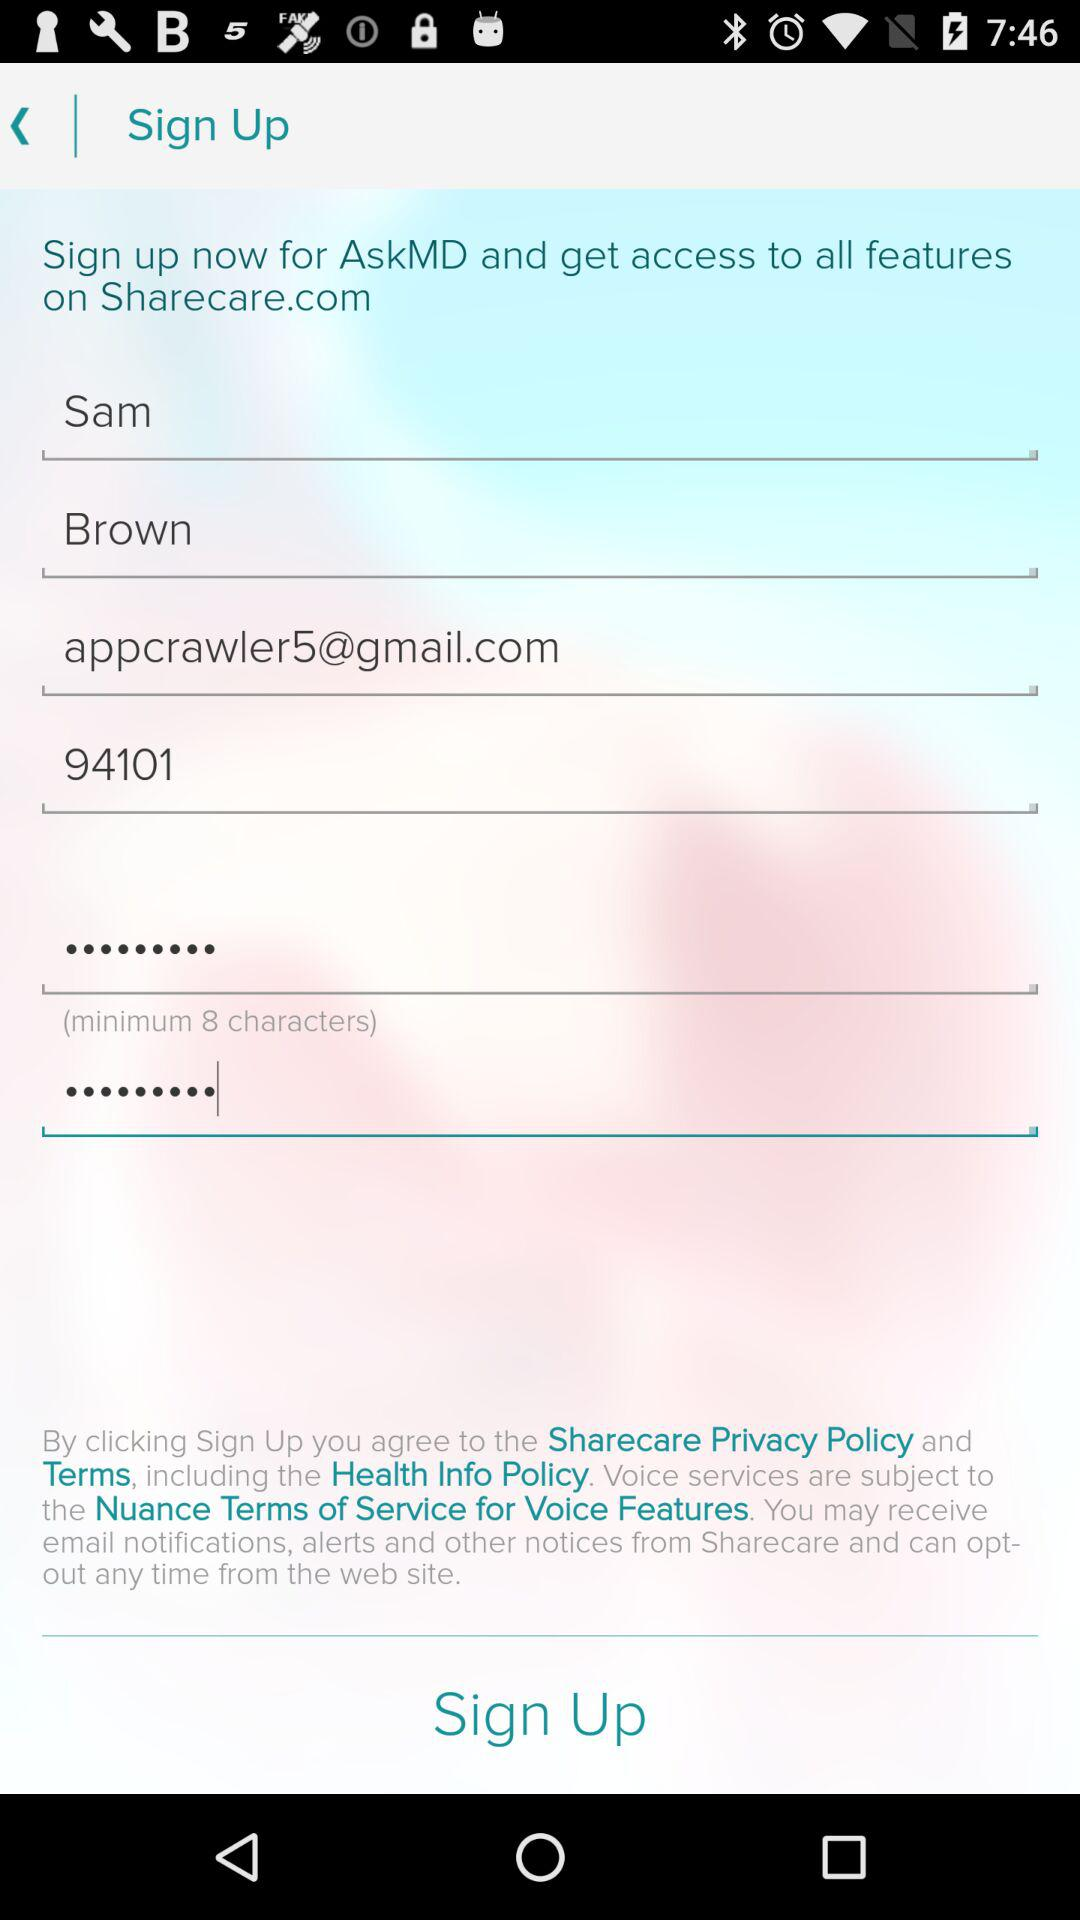What is the user's name? The user's name is Sam Brown. 